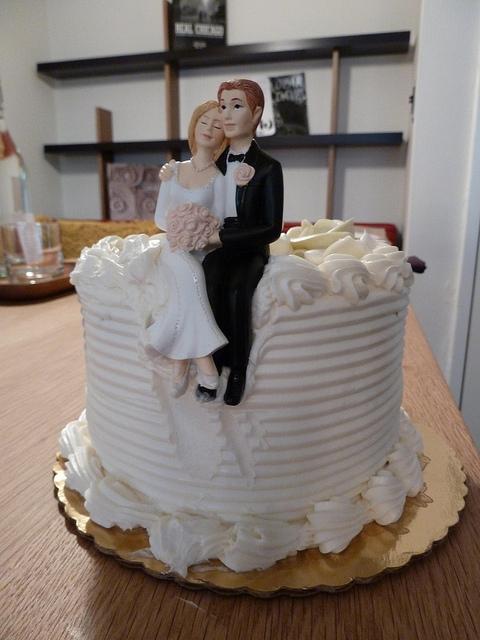Does the caption "The cake has as a part the person." correctly depict the image?
Answer yes or no. Yes. Does the caption "The person is on top of the cake." correctly depict the image?
Answer yes or no. Yes. 